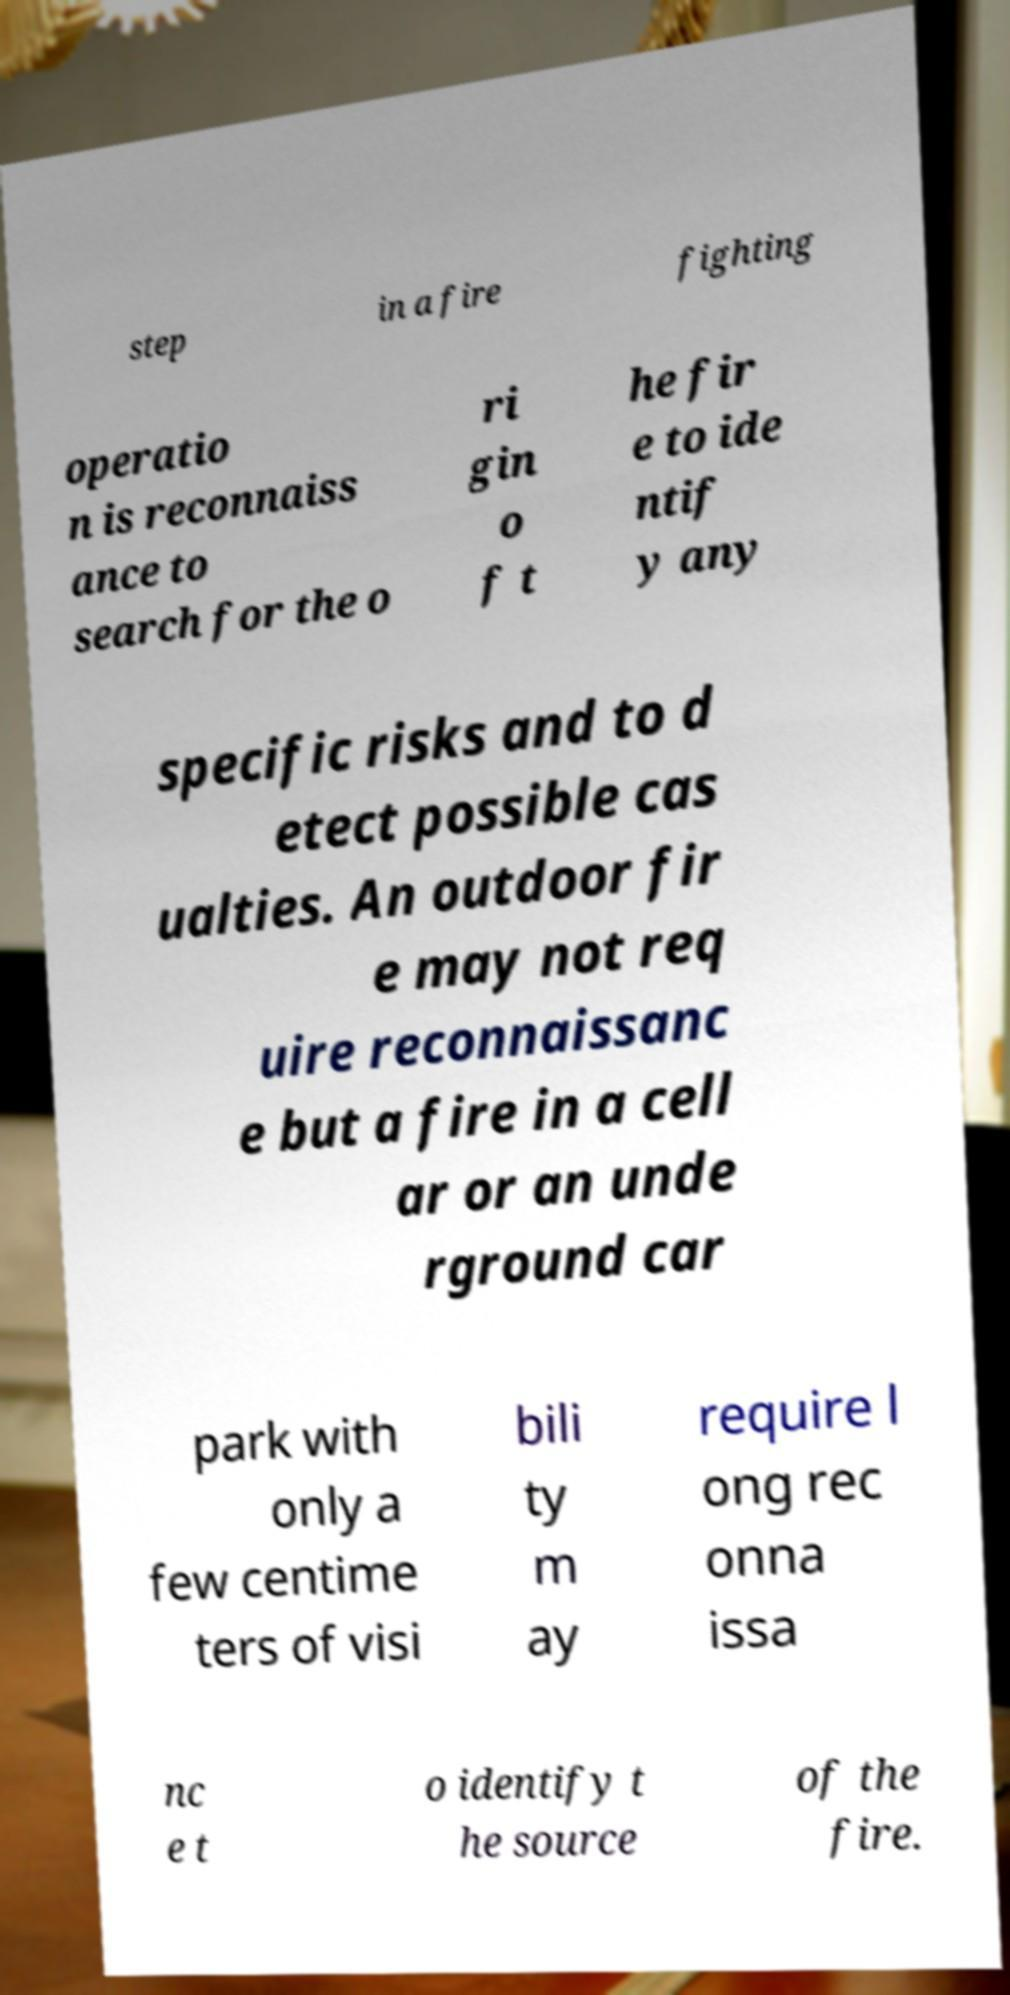I need the written content from this picture converted into text. Can you do that? step in a fire fighting operatio n is reconnaiss ance to search for the o ri gin o f t he fir e to ide ntif y any specific risks and to d etect possible cas ualties. An outdoor fir e may not req uire reconnaissanc e but a fire in a cell ar or an unde rground car park with only a few centime ters of visi bili ty m ay require l ong rec onna issa nc e t o identify t he source of the fire. 